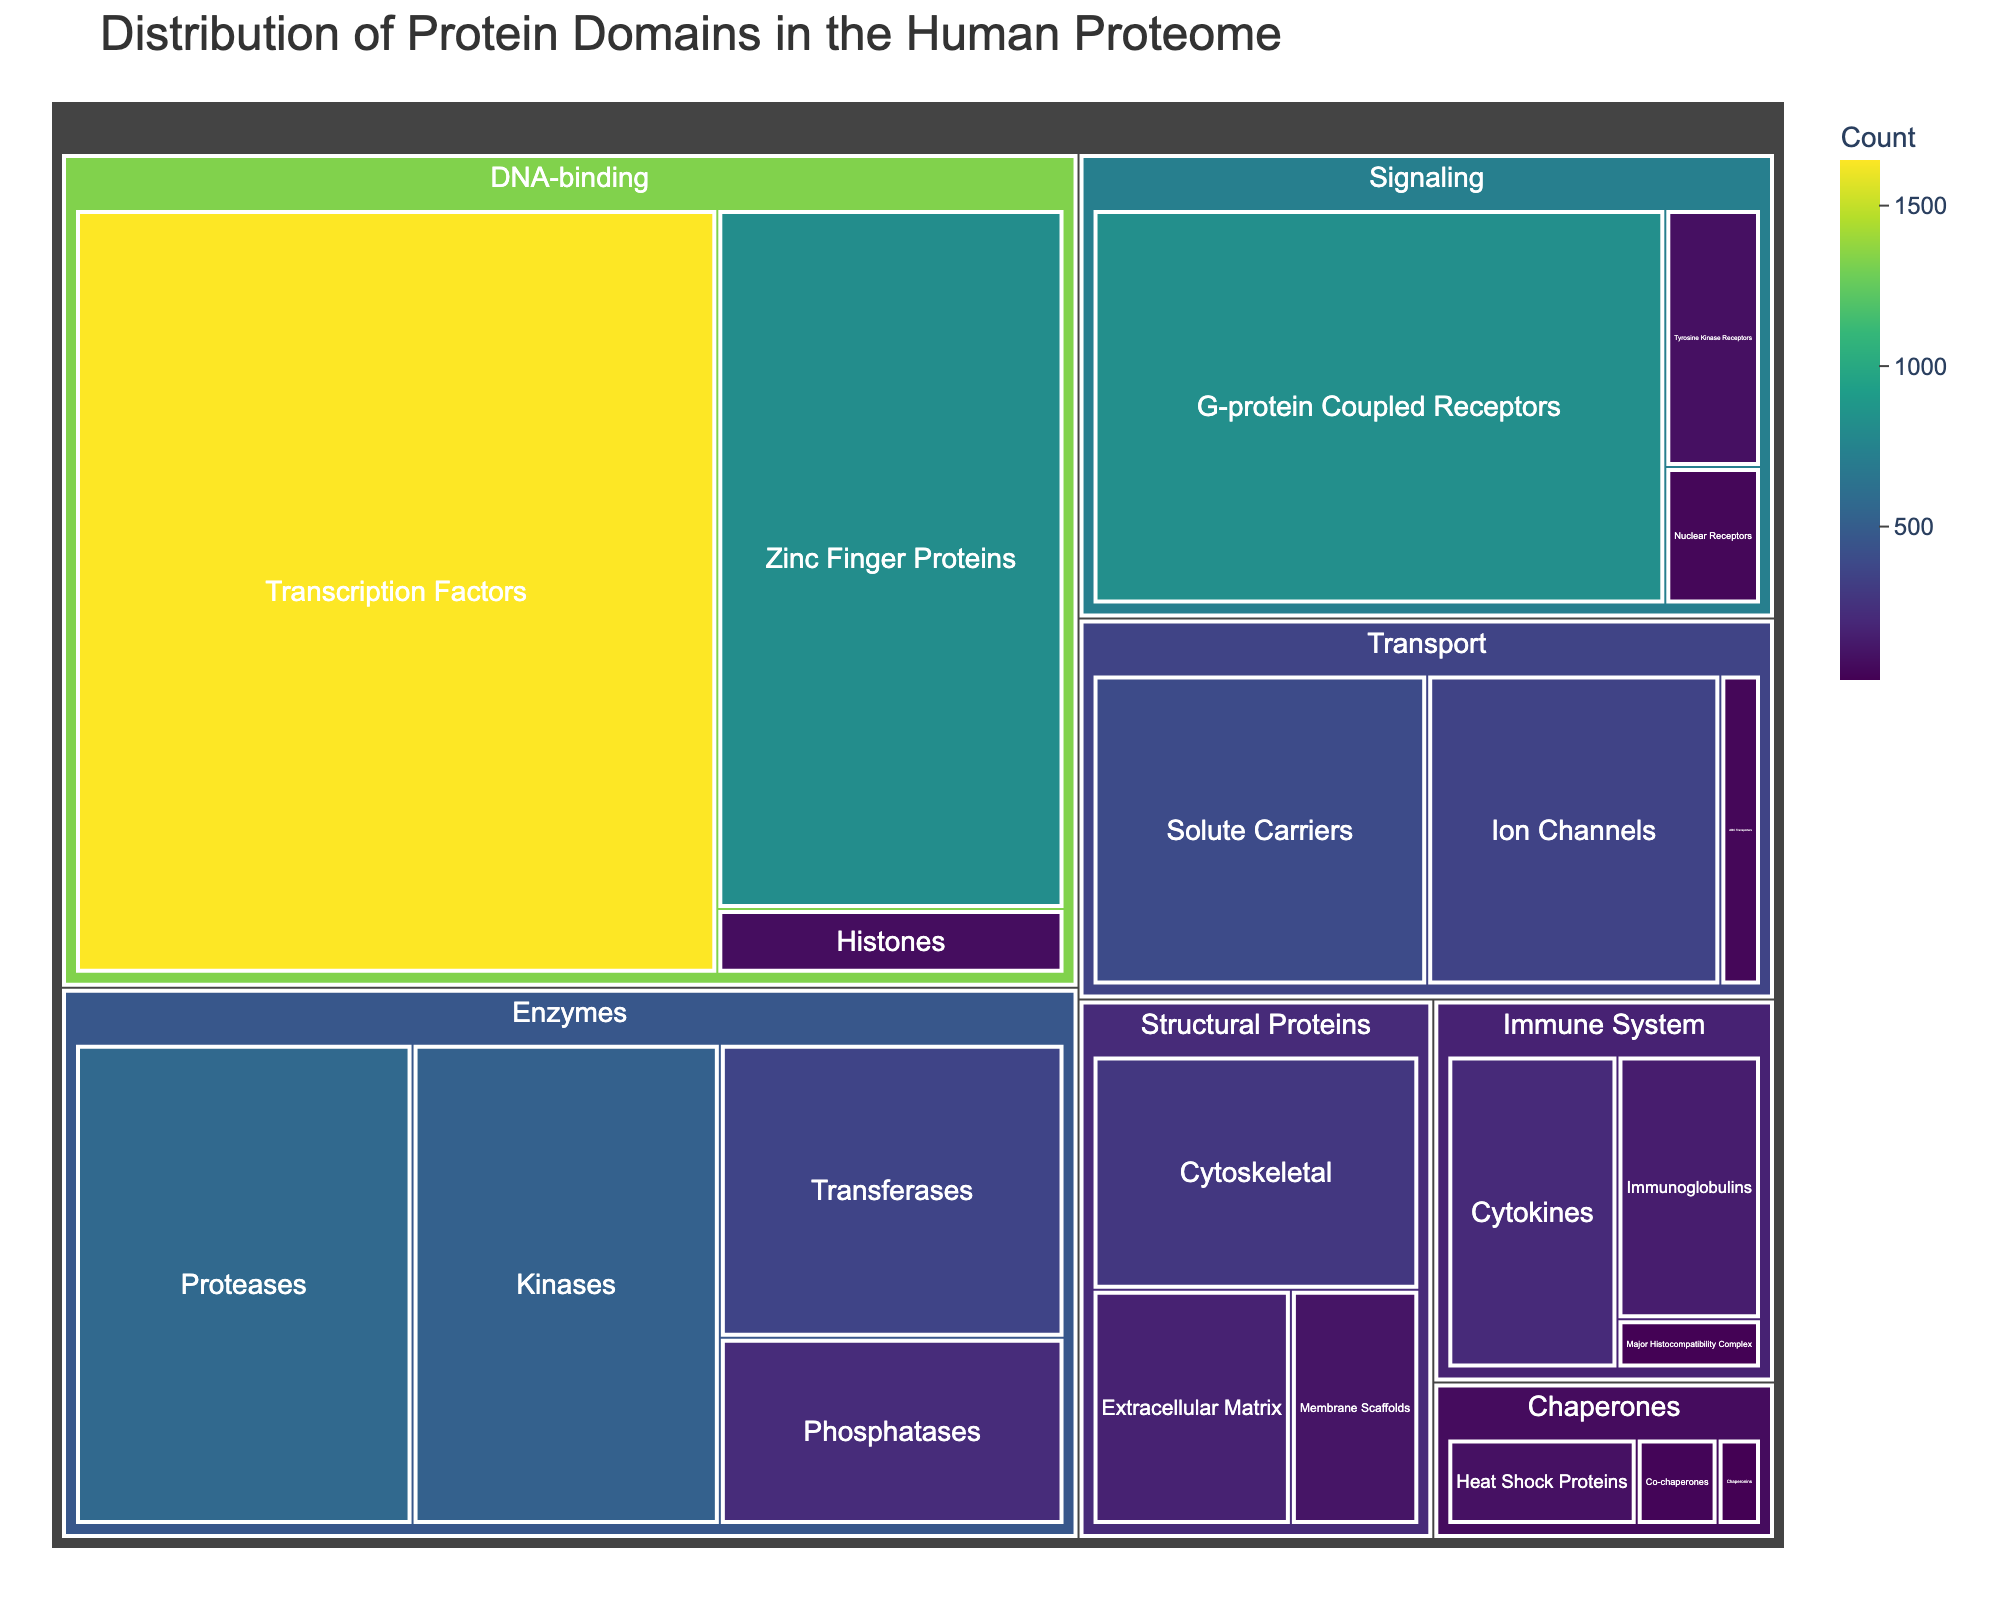What's the title of the figure? The title is clearly shown at the top of the treemap. It states what the figure is about.
Answer: Distribution of Protein Domains in the Human Proteome Which subcategory has the highest count? By examining the tile sizes and labels, the subcategory with the largest area represents the highest count.
Answer: Transcription Factors How many subcategories are there in the category "Enzymes"? Count the number of tiles under the branch labeled "Enzymes."
Answer: Four What is the total count of structural proteins? Sum the counts of all subcategories listed under "Structural Proteins."
Answer: 284 + 173 + 112 = 569 Which category has the smallest total count? Compare the summed counts of each category and identify the one with the lowest total.
Answer: Chaperones Which subcategory of "Signaling" has the lowest count? Look at the sizes and labels of the "Signaling" subcategory tiles to find the smallest one.
Answer: Nuclear Receptors Are the counts for "Ion Channels" and "Transferases" greater than 300? Compare both counts individually to see if each is above 300.
Answer: Both are greater than 300 Which category has more subcategories: "Transport" or "Chaperones"? Count the number of subcategories in each category and compare.
Answer: Transport How does the count of "G-protein Coupled Receptors" compare with "Ion Channels"? Directly compare the numbers from the two subcategories.
Answer: G-protein Coupled Receptors has a higher count Is the count of "Immunoglobulins" more than twice the count of "Nuclear Receptors"? Multiply the count of "Nuclear Receptors" by 2 and check if "Immunoglobulins" exceeds this value.
Answer: No Which subcategory within "DNA-binding" has the second highest count? Rank the subcategories by their counts and find the second largest value.
Answer: Zinc Finger Proteins 